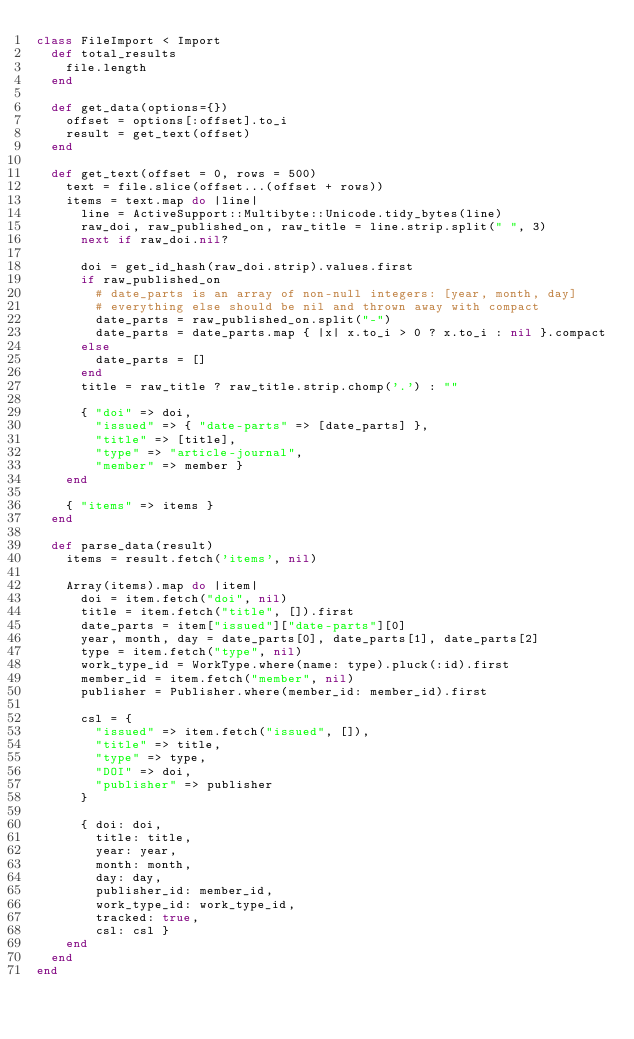<code> <loc_0><loc_0><loc_500><loc_500><_Ruby_>class FileImport < Import
  def total_results
    file.length
  end

  def get_data(options={})
    offset = options[:offset].to_i
    result = get_text(offset)
  end

  def get_text(offset = 0, rows = 500)
    text = file.slice(offset...(offset + rows))
    items = text.map do |line|
      line = ActiveSupport::Multibyte::Unicode.tidy_bytes(line)
      raw_doi, raw_published_on, raw_title = line.strip.split(" ", 3)
      next if raw_doi.nil?

      doi = get_id_hash(raw_doi.strip).values.first
      if raw_published_on
        # date_parts is an array of non-null integers: [year, month, day]
        # everything else should be nil and thrown away with compact
        date_parts = raw_published_on.split("-")
        date_parts = date_parts.map { |x| x.to_i > 0 ? x.to_i : nil }.compact
      else
        date_parts = []
      end
      title = raw_title ? raw_title.strip.chomp('.') : ""

      { "doi" => doi,
        "issued" => { "date-parts" => [date_parts] },
        "title" => [title],
        "type" => "article-journal",
        "member" => member }
    end

    { "items" => items }
  end

  def parse_data(result)
    items = result.fetch('items', nil)

    Array(items).map do |item|
      doi = item.fetch("doi", nil)
      title = item.fetch("title", []).first
      date_parts = item["issued"]["date-parts"][0]
      year, month, day = date_parts[0], date_parts[1], date_parts[2]
      type = item.fetch("type", nil)
      work_type_id = WorkType.where(name: type).pluck(:id).first
      member_id = item.fetch("member", nil)
      publisher = Publisher.where(member_id: member_id).first

      csl = {
        "issued" => item.fetch("issued", []),
        "title" => title,
        "type" => type,
        "DOI" => doi,
        "publisher" => publisher
      }

      { doi: doi,
        title: title,
        year: year,
        month: month,
        day: day,
        publisher_id: member_id,
        work_type_id: work_type_id,
        tracked: true,
        csl: csl }
    end
  end
end
</code> 